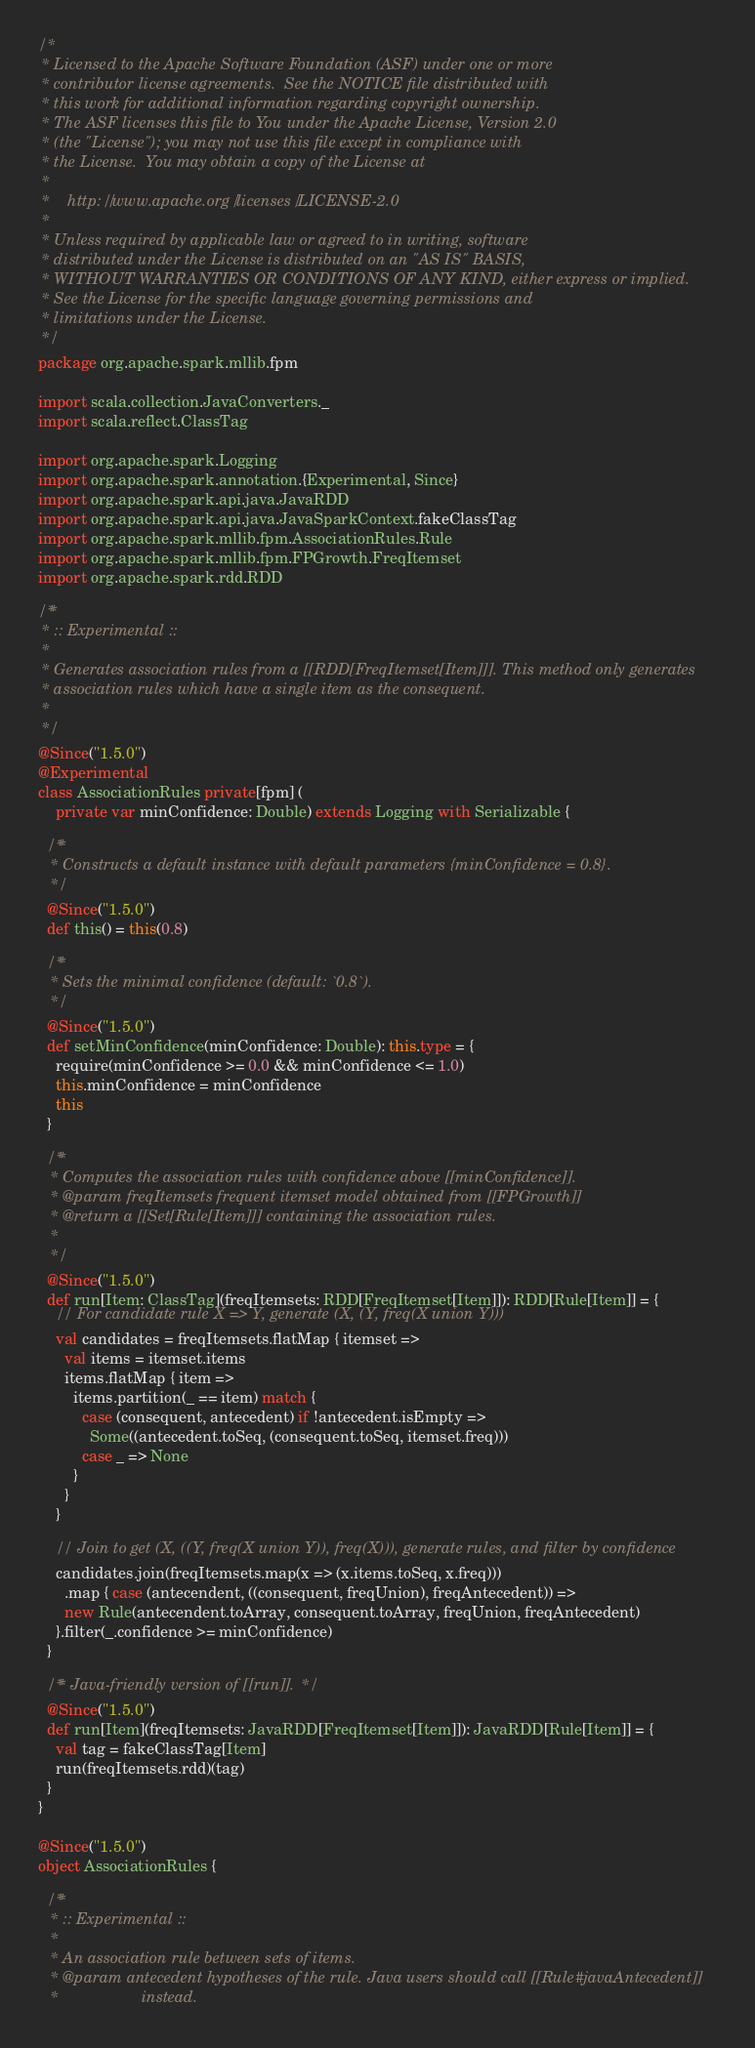Convert code to text. <code><loc_0><loc_0><loc_500><loc_500><_Scala_>/*
 * Licensed to the Apache Software Foundation (ASF) under one or more
 * contributor license agreements.  See the NOTICE file distributed with
 * this work for additional information regarding copyright ownership.
 * The ASF licenses this file to You under the Apache License, Version 2.0
 * (the "License"); you may not use this file except in compliance with
 * the License.  You may obtain a copy of the License at
 *
 *    http://www.apache.org/licenses/LICENSE-2.0
 *
 * Unless required by applicable law or agreed to in writing, software
 * distributed under the License is distributed on an "AS IS" BASIS,
 * WITHOUT WARRANTIES OR CONDITIONS OF ANY KIND, either express or implied.
 * See the License for the specific language governing permissions and
 * limitations under the License.
 */
package org.apache.spark.mllib.fpm

import scala.collection.JavaConverters._
import scala.reflect.ClassTag

import org.apache.spark.Logging
import org.apache.spark.annotation.{Experimental, Since}
import org.apache.spark.api.java.JavaRDD
import org.apache.spark.api.java.JavaSparkContext.fakeClassTag
import org.apache.spark.mllib.fpm.AssociationRules.Rule
import org.apache.spark.mllib.fpm.FPGrowth.FreqItemset
import org.apache.spark.rdd.RDD

/**
 * :: Experimental ::
 *
 * Generates association rules from a [[RDD[FreqItemset[Item]]]. This method only generates
 * association rules which have a single item as the consequent.
 *
 */
@Since("1.5.0")
@Experimental
class AssociationRules private[fpm] (
    private var minConfidence: Double) extends Logging with Serializable {

  /**
   * Constructs a default instance with default parameters {minConfidence = 0.8}.
   */
  @Since("1.5.0")
  def this() = this(0.8)

  /**
   * Sets the minimal confidence (default: `0.8`).
   */
  @Since("1.5.0")
  def setMinConfidence(minConfidence: Double): this.type = {
    require(minConfidence >= 0.0 && minConfidence <= 1.0)
    this.minConfidence = minConfidence
    this
  }

  /**
   * Computes the association rules with confidence above [[minConfidence]].
   * @param freqItemsets frequent itemset model obtained from [[FPGrowth]]
   * @return a [[Set[Rule[Item]]] containing the association rules.
   *
   */
  @Since("1.5.0")
  def run[Item: ClassTag](freqItemsets: RDD[FreqItemset[Item]]): RDD[Rule[Item]] = {
    // For candidate rule X => Y, generate (X, (Y, freq(X union Y)))
    val candidates = freqItemsets.flatMap { itemset =>
      val items = itemset.items
      items.flatMap { item =>
        items.partition(_ == item) match {
          case (consequent, antecedent) if !antecedent.isEmpty =>
            Some((antecedent.toSeq, (consequent.toSeq, itemset.freq)))
          case _ => None
        }
      }
    }

    // Join to get (X, ((Y, freq(X union Y)), freq(X))), generate rules, and filter by confidence
    candidates.join(freqItemsets.map(x => (x.items.toSeq, x.freq)))
      .map { case (antecendent, ((consequent, freqUnion), freqAntecedent)) =>
      new Rule(antecendent.toArray, consequent.toArray, freqUnion, freqAntecedent)
    }.filter(_.confidence >= minConfidence)
  }

  /** Java-friendly version of [[run]]. */
  @Since("1.5.0")
  def run[Item](freqItemsets: JavaRDD[FreqItemset[Item]]): JavaRDD[Rule[Item]] = {
    val tag = fakeClassTag[Item]
    run(freqItemsets.rdd)(tag)
  }
}

@Since("1.5.0")
object AssociationRules {

  /**
   * :: Experimental ::
   *
   * An association rule between sets of items.
   * @param antecedent hypotheses of the rule. Java users should call [[Rule#javaAntecedent]]
   *                   instead.</code> 